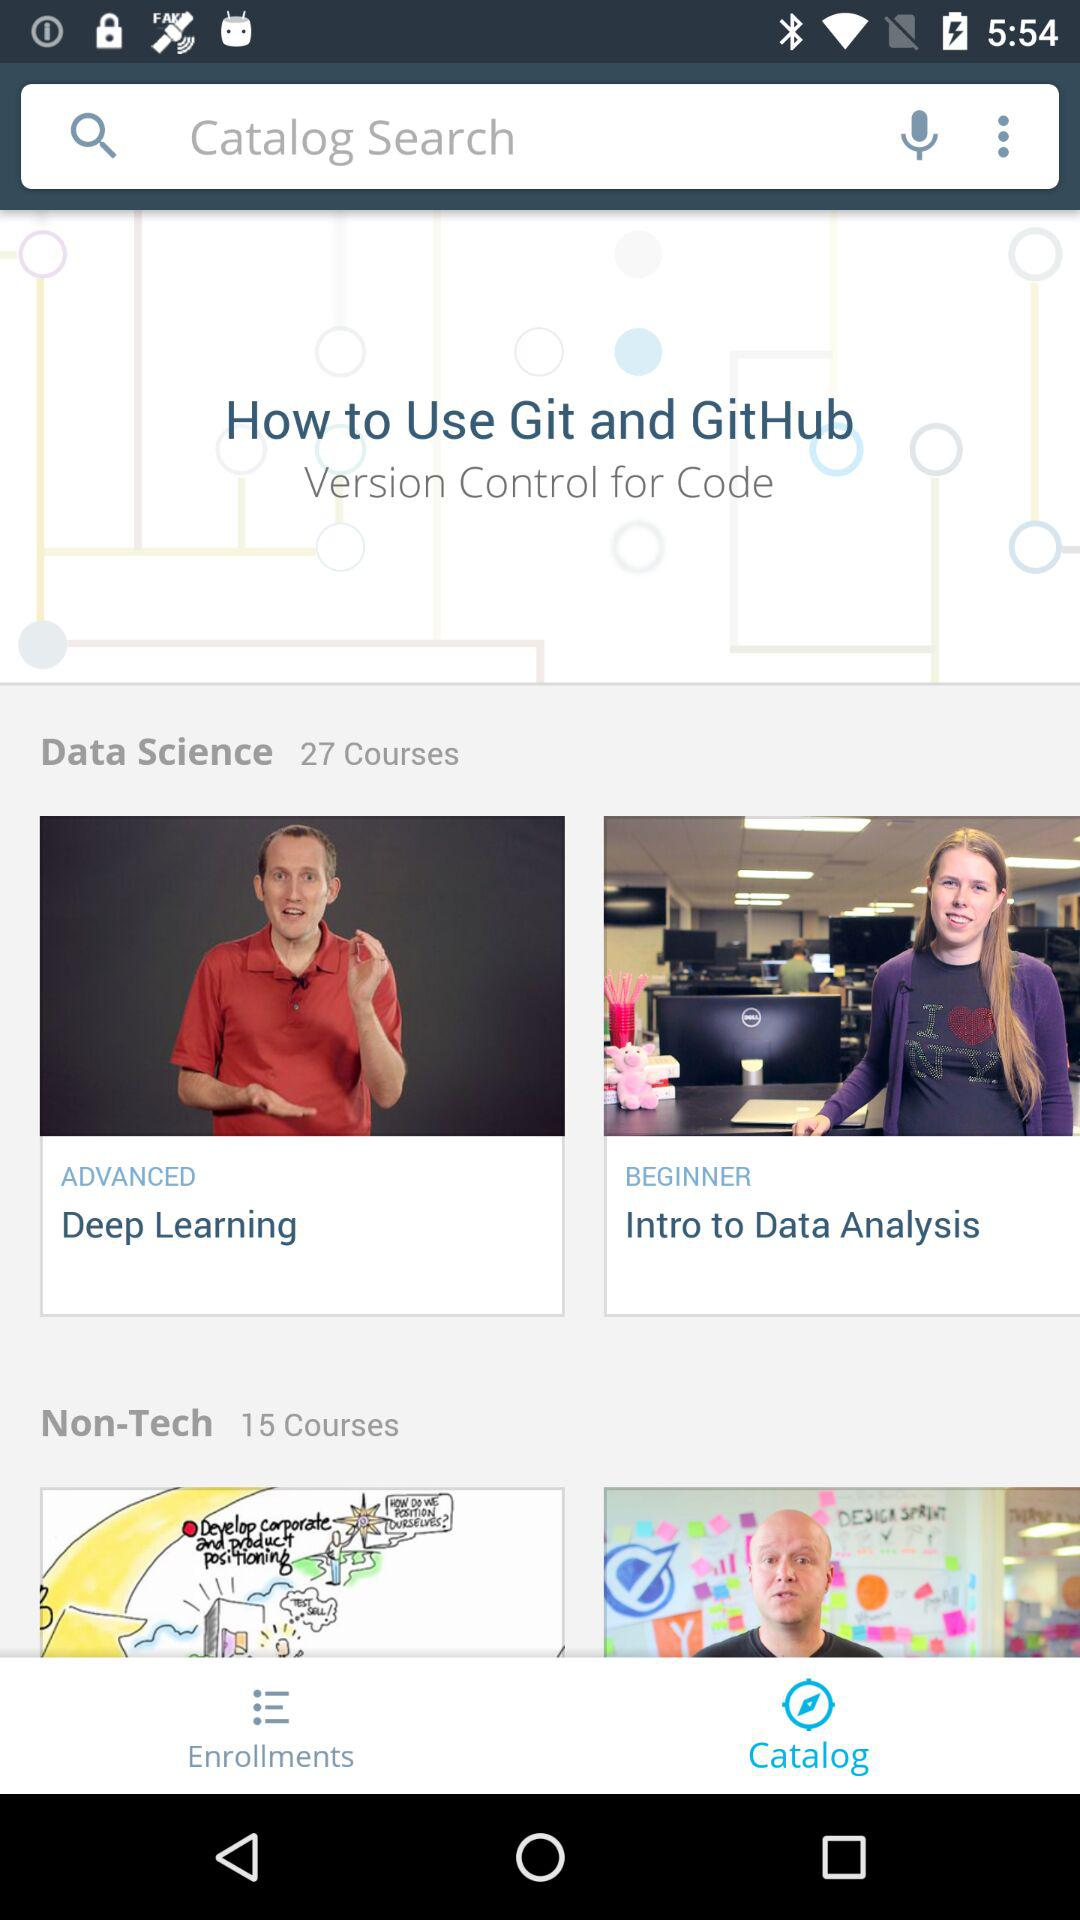How many non-tech courses are available? There are 15 non-tech courses available. 